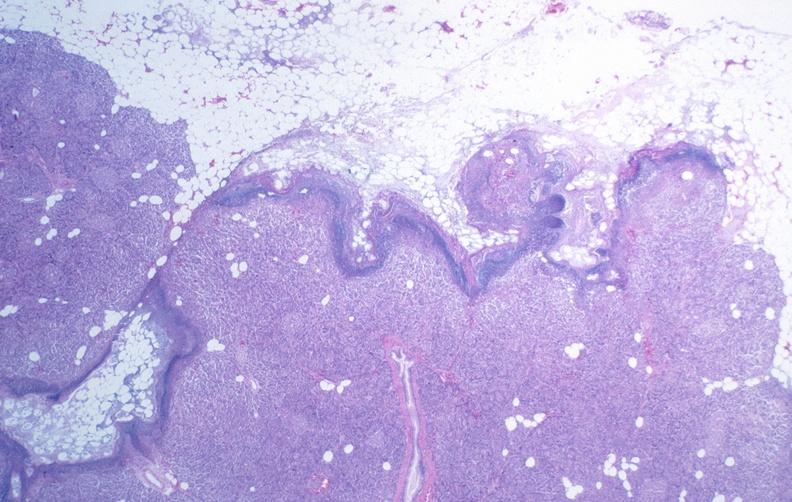where is this?
Answer the question using a single word or phrase. Pancreas 